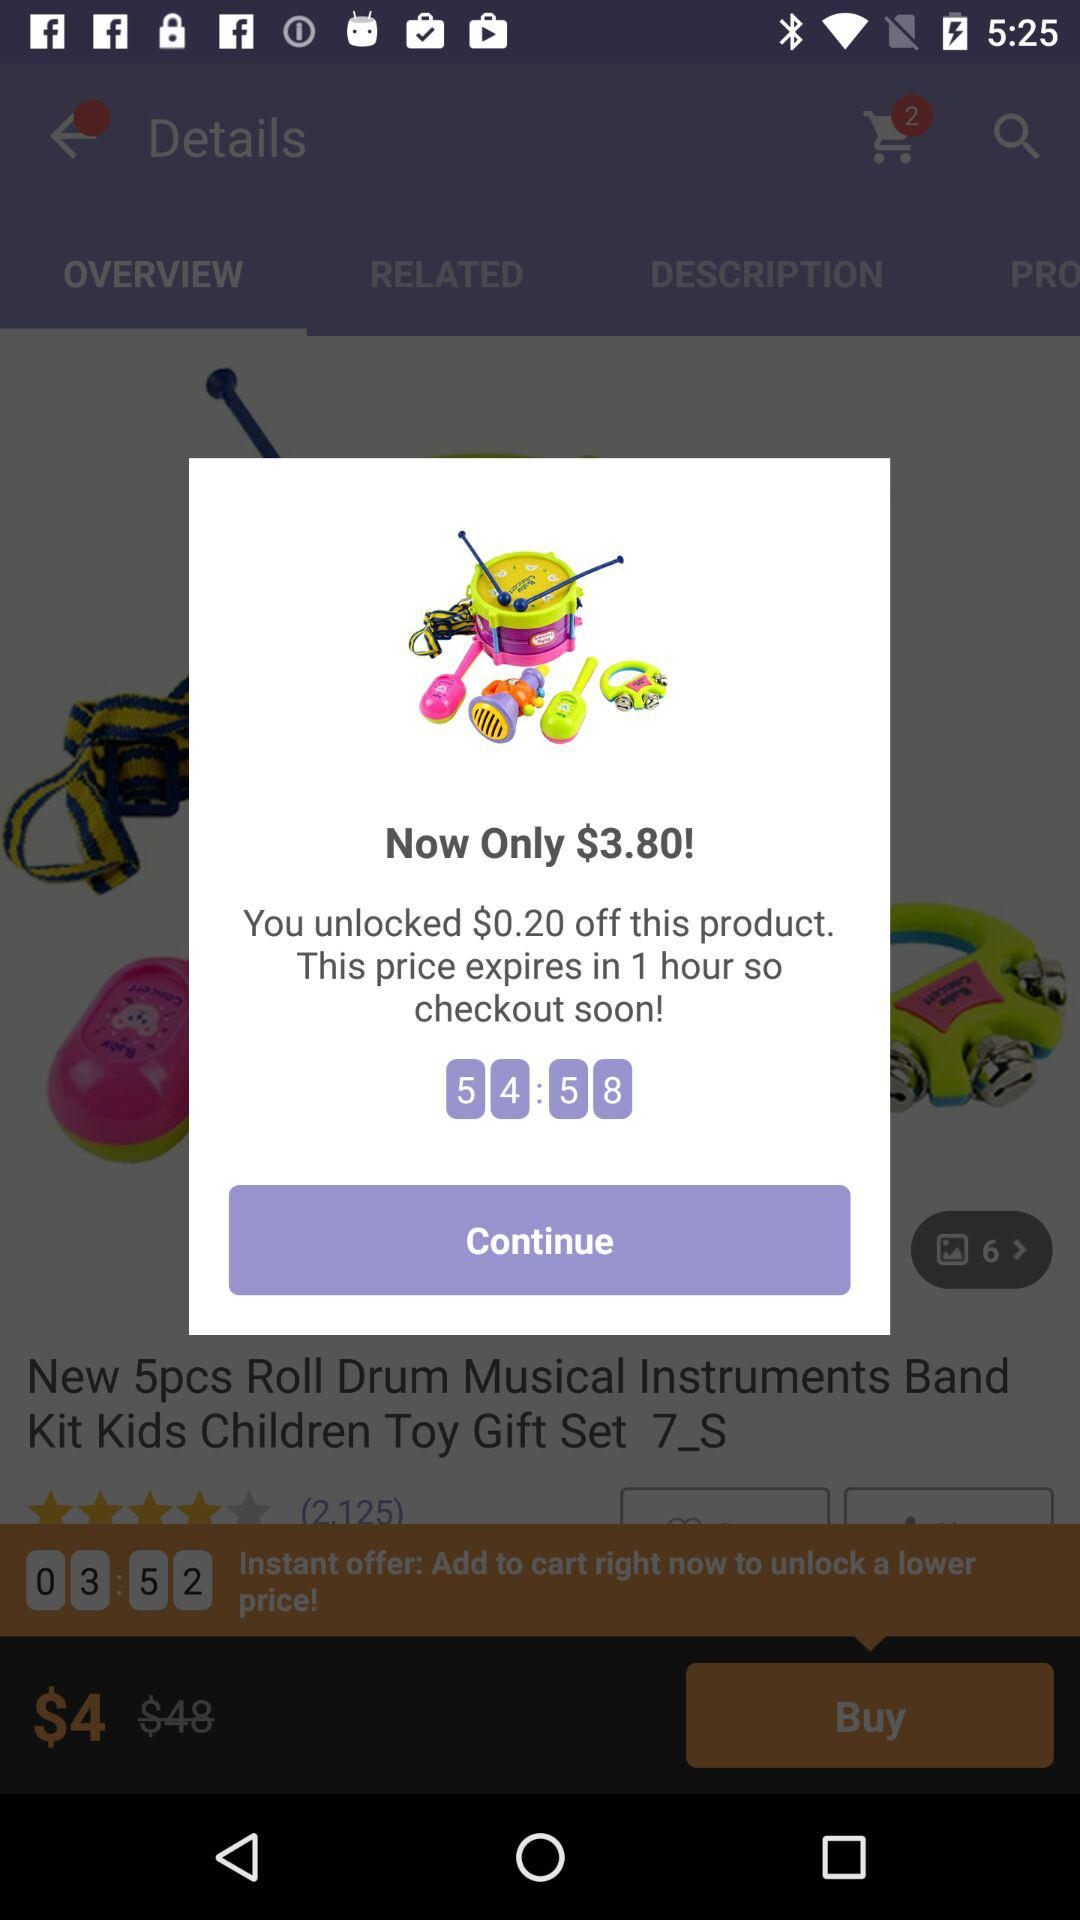What is the buying price? The buying price is $4. 